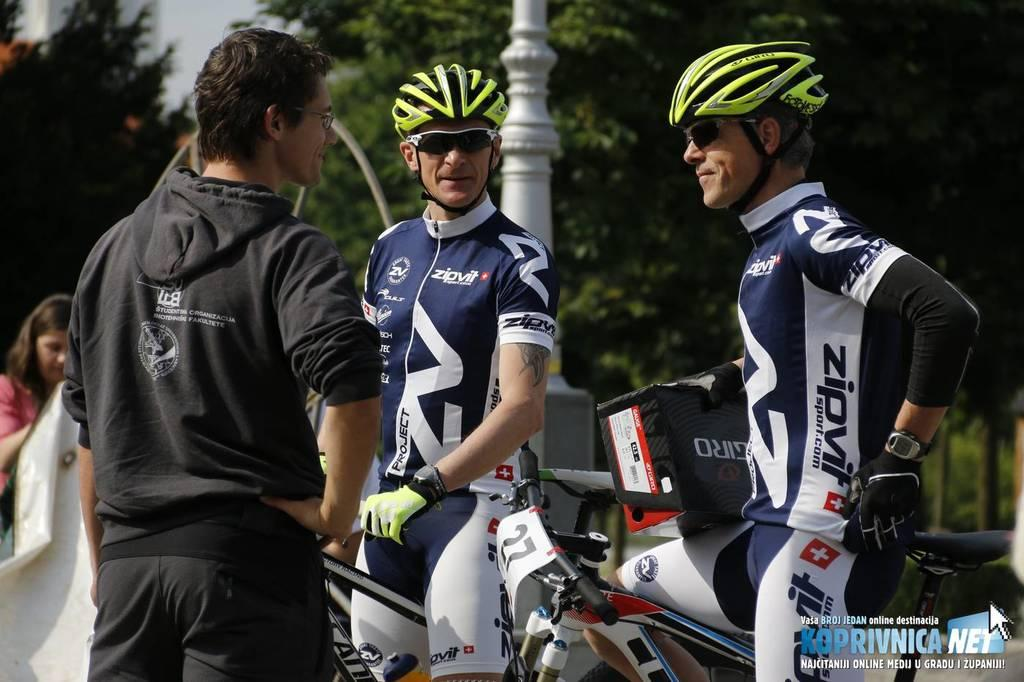What are the two persons in the middle of the image doing? The two persons are standing with their cycles in the middle of the image. What safety equipment are the persons wearing? The persons are wearing helmets and goggles. What type of clothing are the persons wearing? The persons are wearing sports dress. Can you describe the man on the left side of the image? There is a man standing on the left side of the image. How many crates of cherries can be seen on the hill in the image? There are no crates or cherries present in the image, nor is there a hill depicted. 